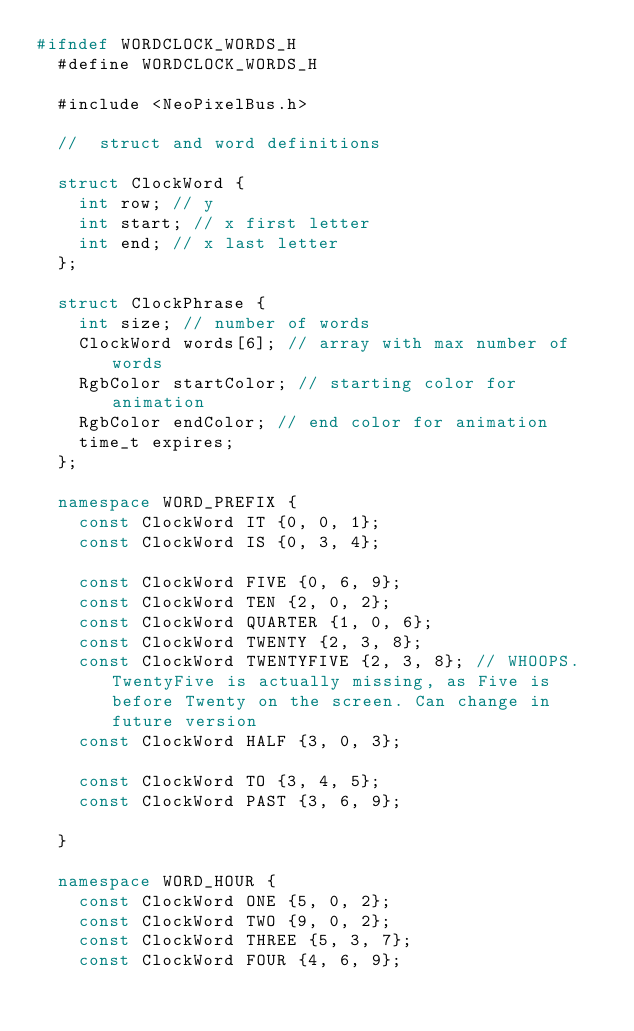Convert code to text. <code><loc_0><loc_0><loc_500><loc_500><_C++_>#ifndef WORDCLOCK_WORDS_H
  #define WORDCLOCK_WORDS_H

  #include <NeoPixelBus.h>

  //  struct and word definitions

  struct ClockWord {
    int row; // y
    int start; // x first letter
    int end; // x last letter
  };

  struct ClockPhrase {
    int size; // number of words
    ClockWord words[6]; // array with max number of words
    RgbColor startColor; // starting color for animation
    RgbColor endColor; // end color for animation
    time_t expires;
  };

  namespace WORD_PREFIX {
    const ClockWord IT {0, 0, 1};
    const ClockWord IS {0, 3, 4};

    const ClockWord FIVE {0, 6, 9};
    const ClockWord TEN {2, 0, 2};
    const ClockWord QUARTER {1, 0, 6};
    const ClockWord TWENTY {2, 3, 8};
    const ClockWord TWENTYFIVE {2, 3, 8}; // WHOOPS. TwentyFive is actually missing, as Five is before Twenty on the screen. Can change in future version
    const ClockWord HALF {3, 0, 3};

    const ClockWord TO {3, 4, 5};
    const ClockWord PAST {3, 6, 9};

  }

  namespace WORD_HOUR {
    const ClockWord ONE {5, 0, 2};
    const ClockWord TWO {9, 0, 2};
    const ClockWord THREE {5, 3, 7};
    const ClockWord FOUR {4, 6, 9};</code> 